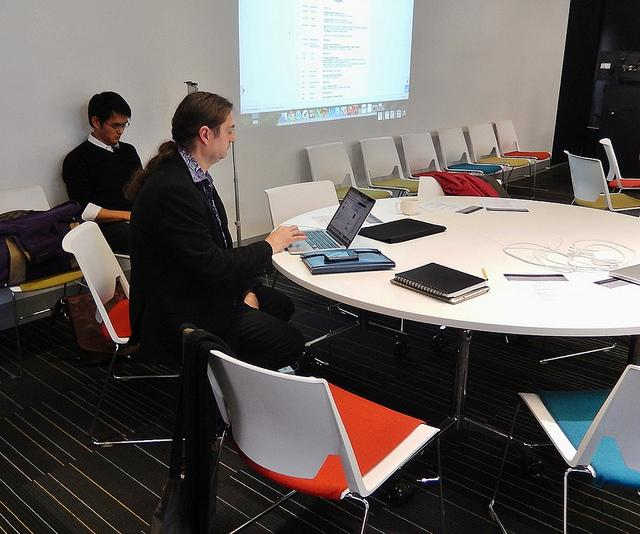What is the operating system being projected?

Choices:
A) mac os
B) ms dos
C) linux
D) windows mac os 